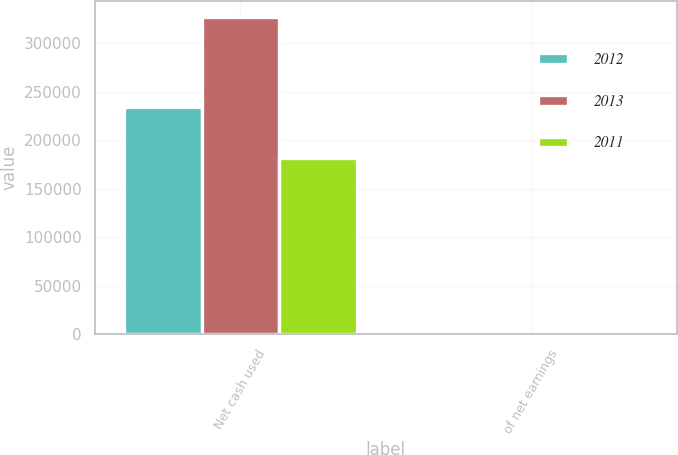Convert chart to OTSL. <chart><loc_0><loc_0><loc_500><loc_500><stacked_bar_chart><ecel><fcel>Net cash used<fcel>of net earnings<nl><fcel>2012<fcel>234443<fcel>52.3<nl><fcel>2013<fcel>327513<fcel>77.9<nl><fcel>2011<fcel>181819<fcel>50.8<nl></chart> 